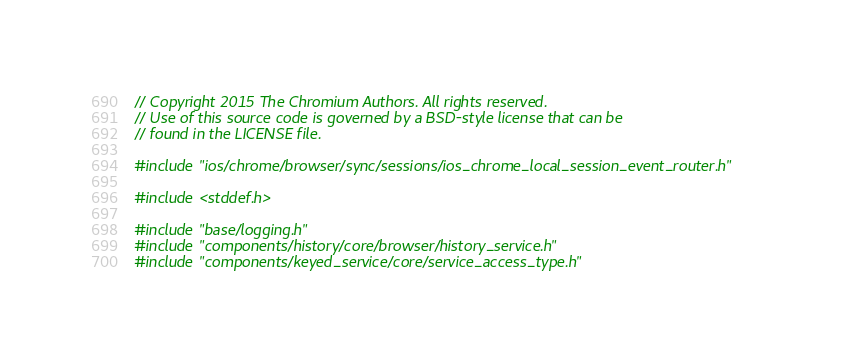<code> <loc_0><loc_0><loc_500><loc_500><_C++_>// Copyright 2015 The Chromium Authors. All rights reserved.
// Use of this source code is governed by a BSD-style license that can be
// found in the LICENSE file.

#include "ios/chrome/browser/sync/sessions/ios_chrome_local_session_event_router.h"

#include <stddef.h>

#include "base/logging.h"
#include "components/history/core/browser/history_service.h"
#include "components/keyed_service/core/service_access_type.h"</code> 